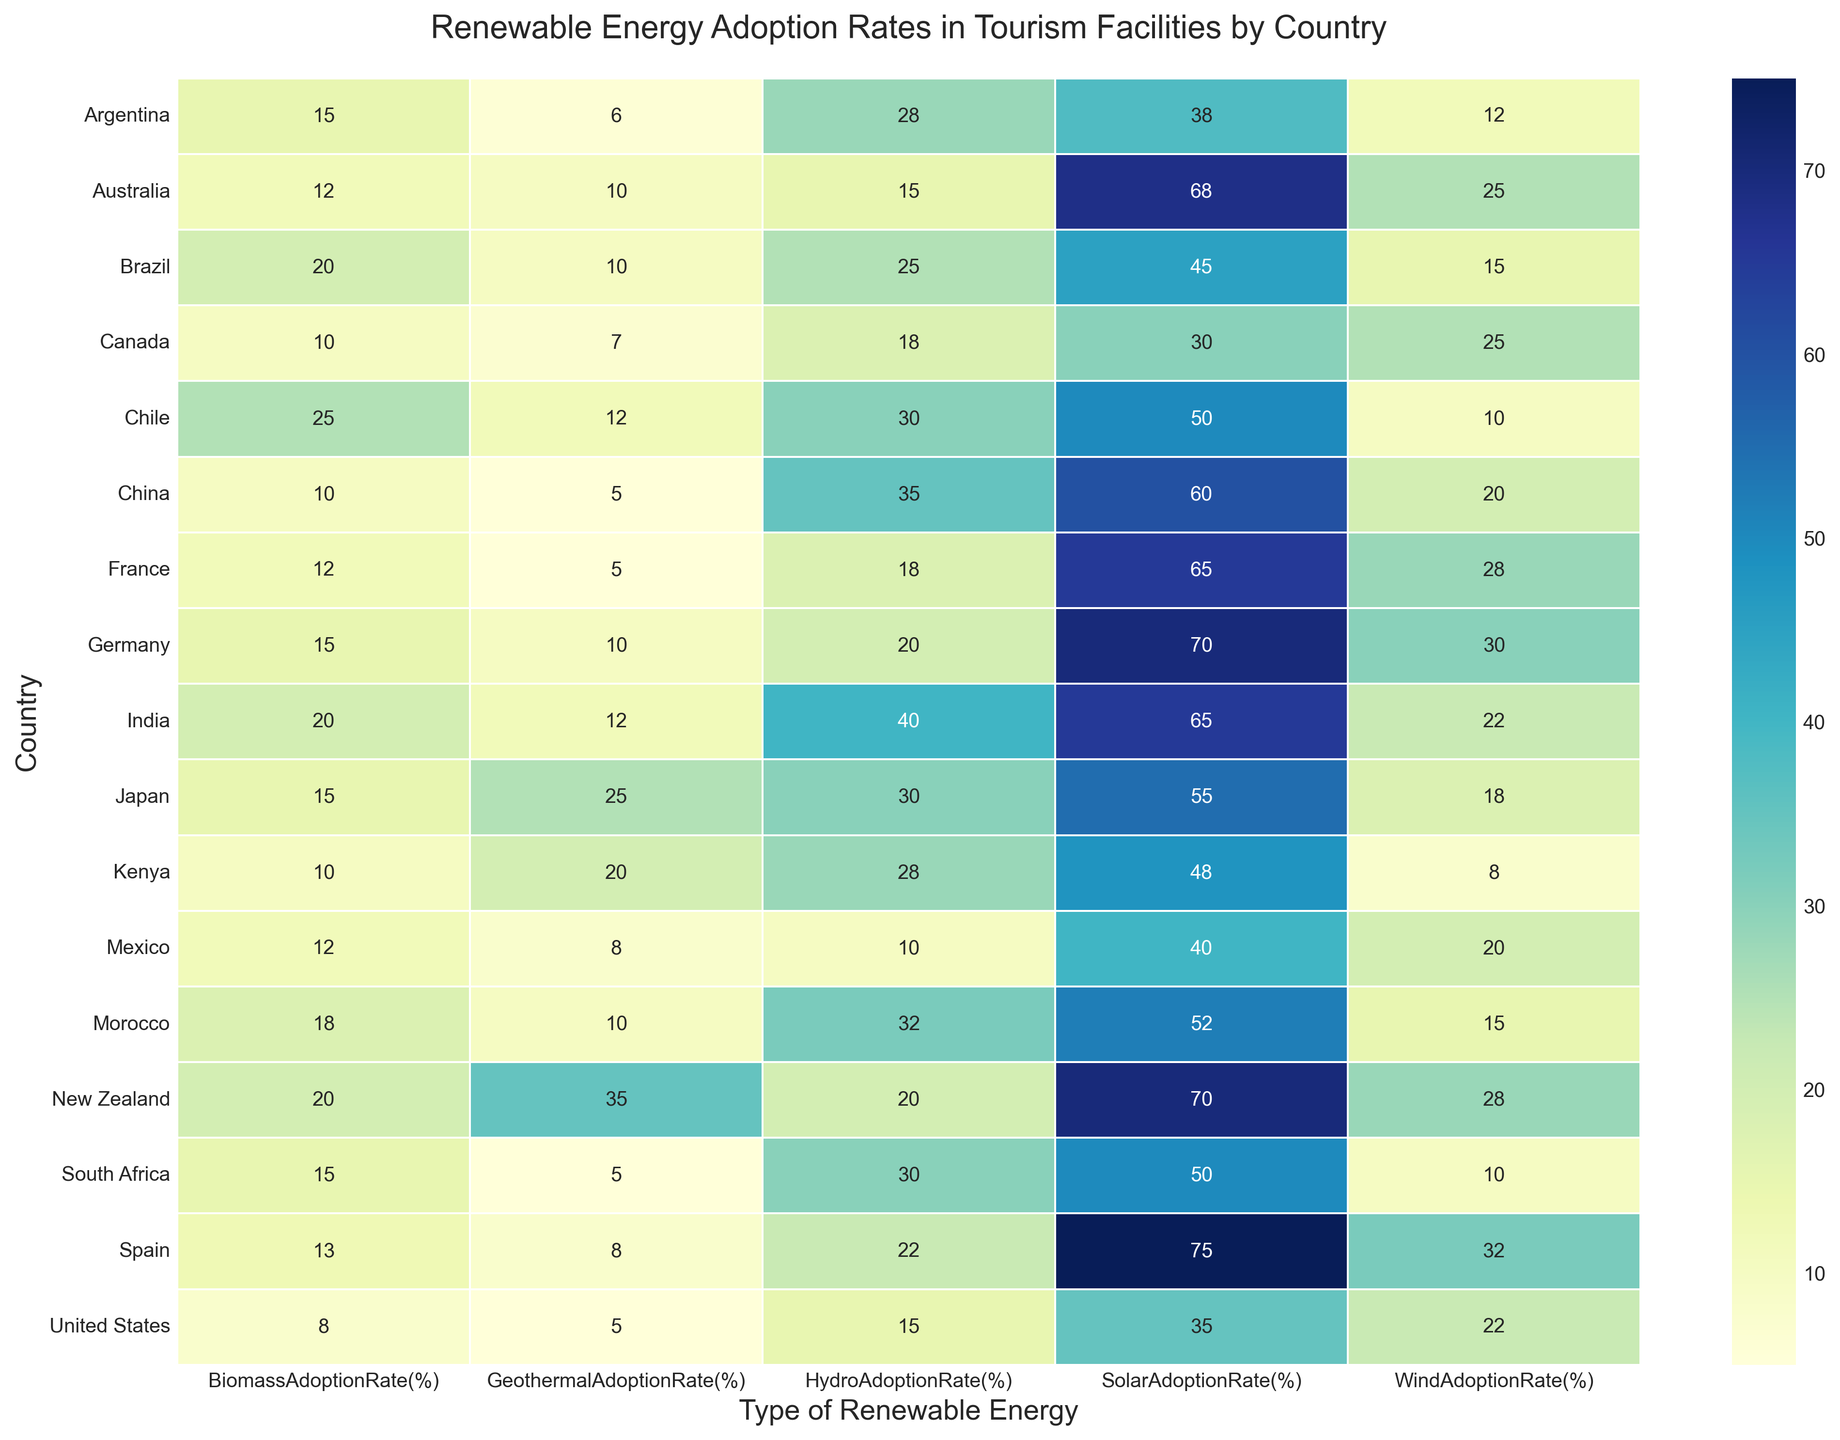Which country has the highest solar adoption rate in tourism facilities? By examining the color intensity of the "SolarAdoptionRate(%)" column, we identify the darkest tint indicating the highest adoption rate. The data shows Spain with a solar adoption rate of 75%
Answer: Spain Which region in the heatmap shows the most diversity in renewable energy adoption rates across different types? Look at the range of colors in each region's row. Europe exhibits high variability with diverse adoption rates across solar, wind, hydro, geothermal, and biomass energy
Answer: Europe Compare the wind adoption rates in North America. Which country has the highest rate? By comparing the color intensities in the "WindAdoptionRate(%)" column within North America, it is evident that Canada has the darkest shade, indicating the highest adoption rate at 25%
Answer: Canada Among African countries, which type of renewable energy shows the lowest adoption rate and by how much? By examining the African countries' rows and focusing on the lightest color in terms of adoption, we find that Kenya has the lowest wind adoption rate at 8%
Answer: Wind, 8% What is the median solar adoption rate among the countries listed? First, list the solar adoption rates: 35, 30, 40, 45, 38, 50, 70, 65, 75, 60, 55, 65, 68, 70, 50, 48, 52. Order these rates: 30, 35, 38, 40, 45, 48, 50, 50, 52, 55, 60, 65, 65, 68, 70, 70, 75. The median is the middle value of the ordered list, which is 52%
Answer: 52% Which country has the same adoption rate for geothermal and biomass energies in their tourism facilities? By comparing the values in the geothermal and biomass columns, Japan has the same adoption rate of 25% for both
Answer: Japan Which type of renewable energy has the highest adoption rate in Argentina’s tourism facilities? Look at the numbers in the row for Argentina; the highest value is 28%, which corresponds to hydro energy
Answer: Hydro Which country in Asia has the highest adoption rate for geothermal energy? By examining the colors in the geothermal column for Asian countries, Japan stands out with 25%
Answer: Japan What is the difference in solar adoption rates between Germany and the United States? Refer to the solar adoption rates of both countries: Germany (70%), United States (35%). The difference is calculated as 70% - 35% = 35%
Answer: 35% In Oceania, which country has the highest biodiversity of renewable energy sources in its tourism facilities in terms of adoption rates? Look at the color variability in the rows for Australia and New Zealand. New Zealand stands out with high variability and notable adoption rates, including a significantly high 35% for geothermal
Answer: New Zealand 